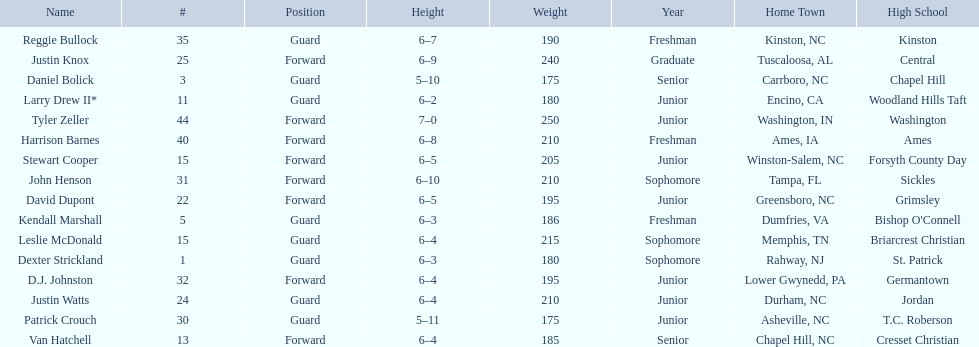Tallest player on the team Tyler Zeller. 